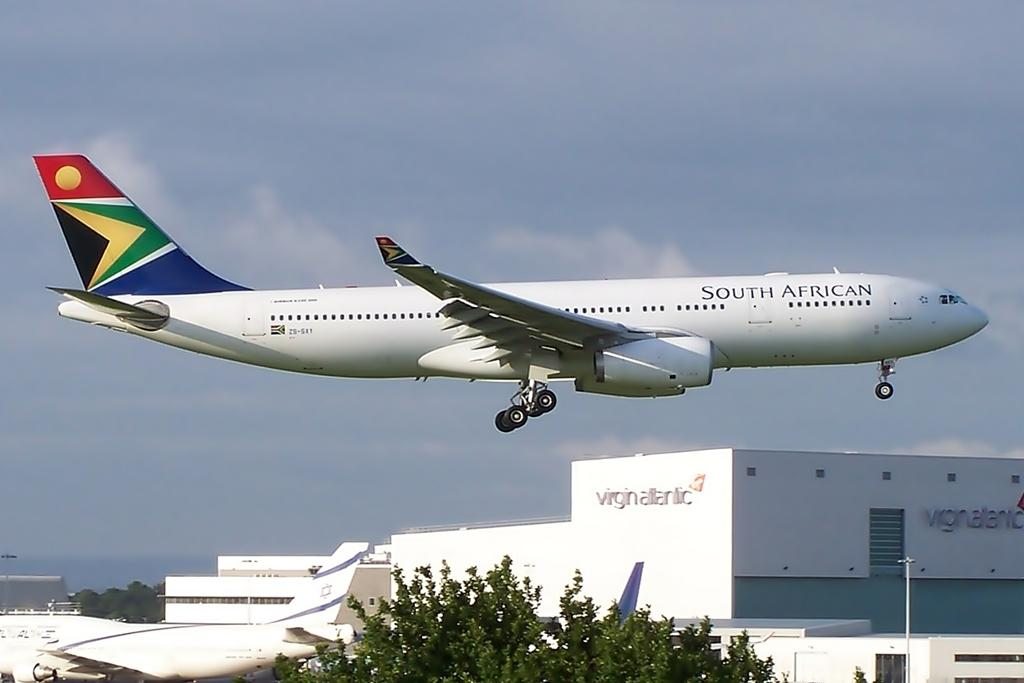<image>
Relay a brief, clear account of the picture shown. A South African airways jet flies at a low altitude over airport buildings. 